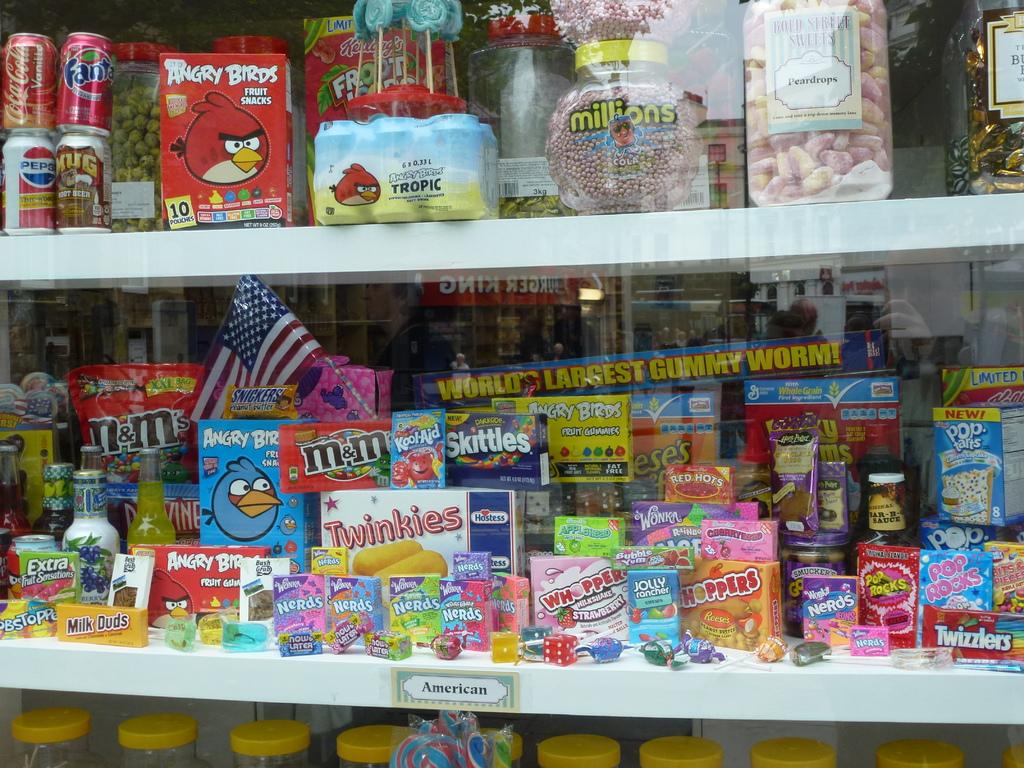What country do these snacks belong to?
Your response must be concise. America. What well-known candy is next to the package with the blue angry bird on it?
Provide a short and direct response. M&ms. 